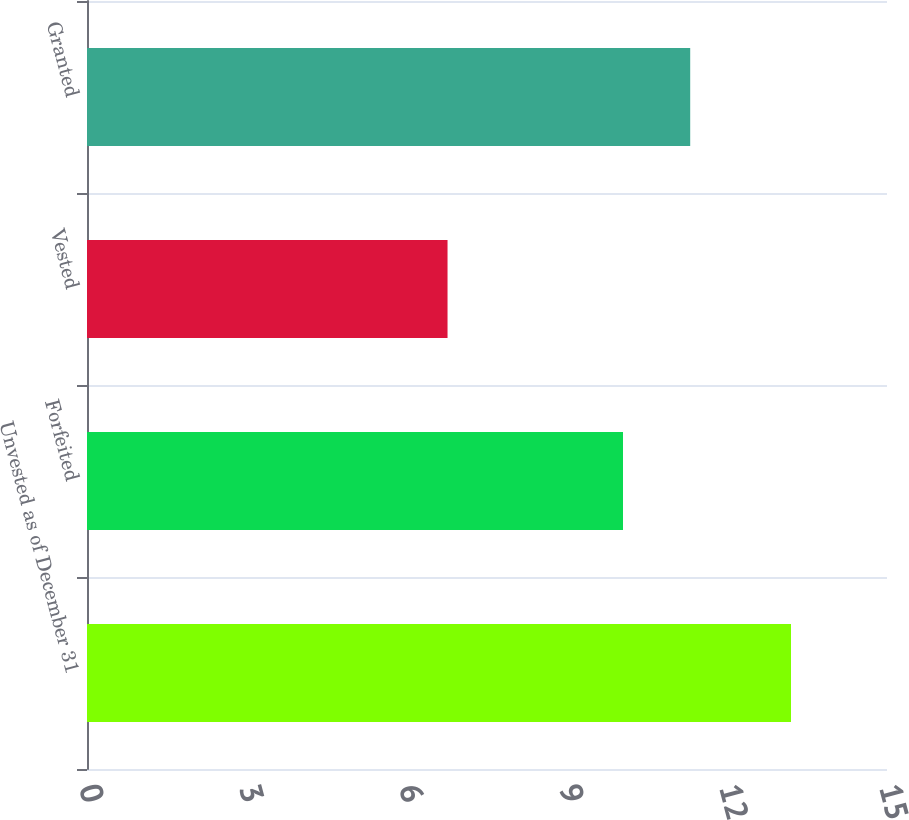Convert chart to OTSL. <chart><loc_0><loc_0><loc_500><loc_500><bar_chart><fcel>Unvested as of December 31<fcel>Forfeited<fcel>Vested<fcel>Granted<nl><fcel>13.2<fcel>10.05<fcel>6.76<fcel>11.31<nl></chart> 